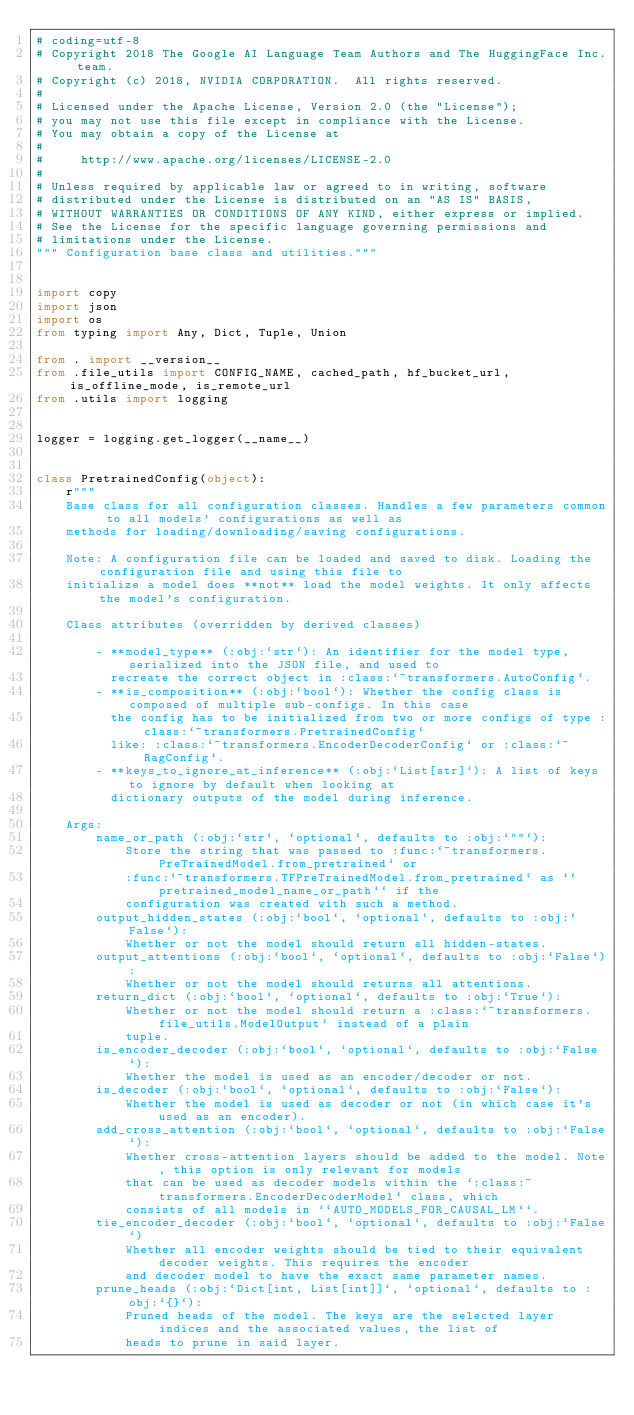<code> <loc_0><loc_0><loc_500><loc_500><_Python_># coding=utf-8
# Copyright 2018 The Google AI Language Team Authors and The HuggingFace Inc. team.
# Copyright (c) 2018, NVIDIA CORPORATION.  All rights reserved.
#
# Licensed under the Apache License, Version 2.0 (the "License");
# you may not use this file except in compliance with the License.
# You may obtain a copy of the License at
#
#     http://www.apache.org/licenses/LICENSE-2.0
#
# Unless required by applicable law or agreed to in writing, software
# distributed under the License is distributed on an "AS IS" BASIS,
# WITHOUT WARRANTIES OR CONDITIONS OF ANY KIND, either express or implied.
# See the License for the specific language governing permissions and
# limitations under the License.
""" Configuration base class and utilities."""


import copy
import json
import os
from typing import Any, Dict, Tuple, Union

from . import __version__
from .file_utils import CONFIG_NAME, cached_path, hf_bucket_url, is_offline_mode, is_remote_url
from .utils import logging


logger = logging.get_logger(__name__)


class PretrainedConfig(object):
    r"""
    Base class for all configuration classes. Handles a few parameters common to all models' configurations as well as
    methods for loading/downloading/saving configurations.

    Note: A configuration file can be loaded and saved to disk. Loading the configuration file and using this file to
    initialize a model does **not** load the model weights. It only affects the model's configuration.

    Class attributes (overridden by derived classes)

        - **model_type** (:obj:`str`): An identifier for the model type, serialized into the JSON file, and used to
          recreate the correct object in :class:`~transformers.AutoConfig`.
        - **is_composition** (:obj:`bool`): Whether the config class is composed of multiple sub-configs. In this case
          the config has to be initialized from two or more configs of type :class:`~transformers.PretrainedConfig`
          like: :class:`~transformers.EncoderDecoderConfig` or :class:`~RagConfig`.
        - **keys_to_ignore_at_inference** (:obj:`List[str]`): A list of keys to ignore by default when looking at
          dictionary outputs of the model during inference.

    Args:
        name_or_path (:obj:`str`, `optional`, defaults to :obj:`""`):
            Store the string that was passed to :func:`~transformers.PreTrainedModel.from_pretrained` or
            :func:`~transformers.TFPreTrainedModel.from_pretrained` as ``pretrained_model_name_or_path`` if the
            configuration was created with such a method.
        output_hidden_states (:obj:`bool`, `optional`, defaults to :obj:`False`):
            Whether or not the model should return all hidden-states.
        output_attentions (:obj:`bool`, `optional`, defaults to :obj:`False`):
            Whether or not the model should returns all attentions.
        return_dict (:obj:`bool`, `optional`, defaults to :obj:`True`):
            Whether or not the model should return a :class:`~transformers.file_utils.ModelOutput` instead of a plain
            tuple.
        is_encoder_decoder (:obj:`bool`, `optional`, defaults to :obj:`False`):
            Whether the model is used as an encoder/decoder or not.
        is_decoder (:obj:`bool`, `optional`, defaults to :obj:`False`):
            Whether the model is used as decoder or not (in which case it's used as an encoder).
        add_cross_attention (:obj:`bool`, `optional`, defaults to :obj:`False`):
            Whether cross-attention layers should be added to the model. Note, this option is only relevant for models
            that can be used as decoder models within the `:class:~transformers.EncoderDecoderModel` class, which
            consists of all models in ``AUTO_MODELS_FOR_CAUSAL_LM``.
        tie_encoder_decoder (:obj:`bool`, `optional`, defaults to :obj:`False`)
            Whether all encoder weights should be tied to their equivalent decoder weights. This requires the encoder
            and decoder model to have the exact same parameter names.
        prune_heads (:obj:`Dict[int, List[int]]`, `optional`, defaults to :obj:`{}`):
            Pruned heads of the model. The keys are the selected layer indices and the associated values, the list of
            heads to prune in said layer.
</code> 